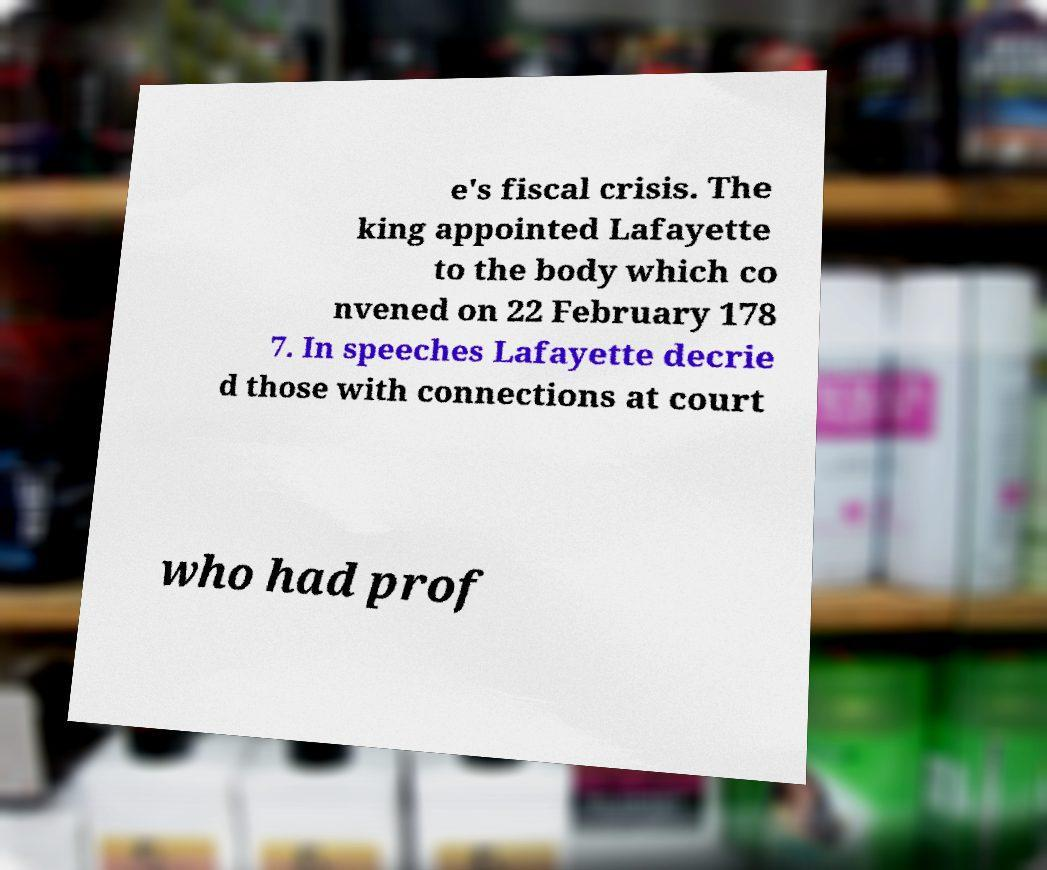There's text embedded in this image that I need extracted. Can you transcribe it verbatim? e's fiscal crisis. The king appointed Lafayette to the body which co nvened on 22 February 178 7. In speeches Lafayette decrie d those with connections at court who had prof 